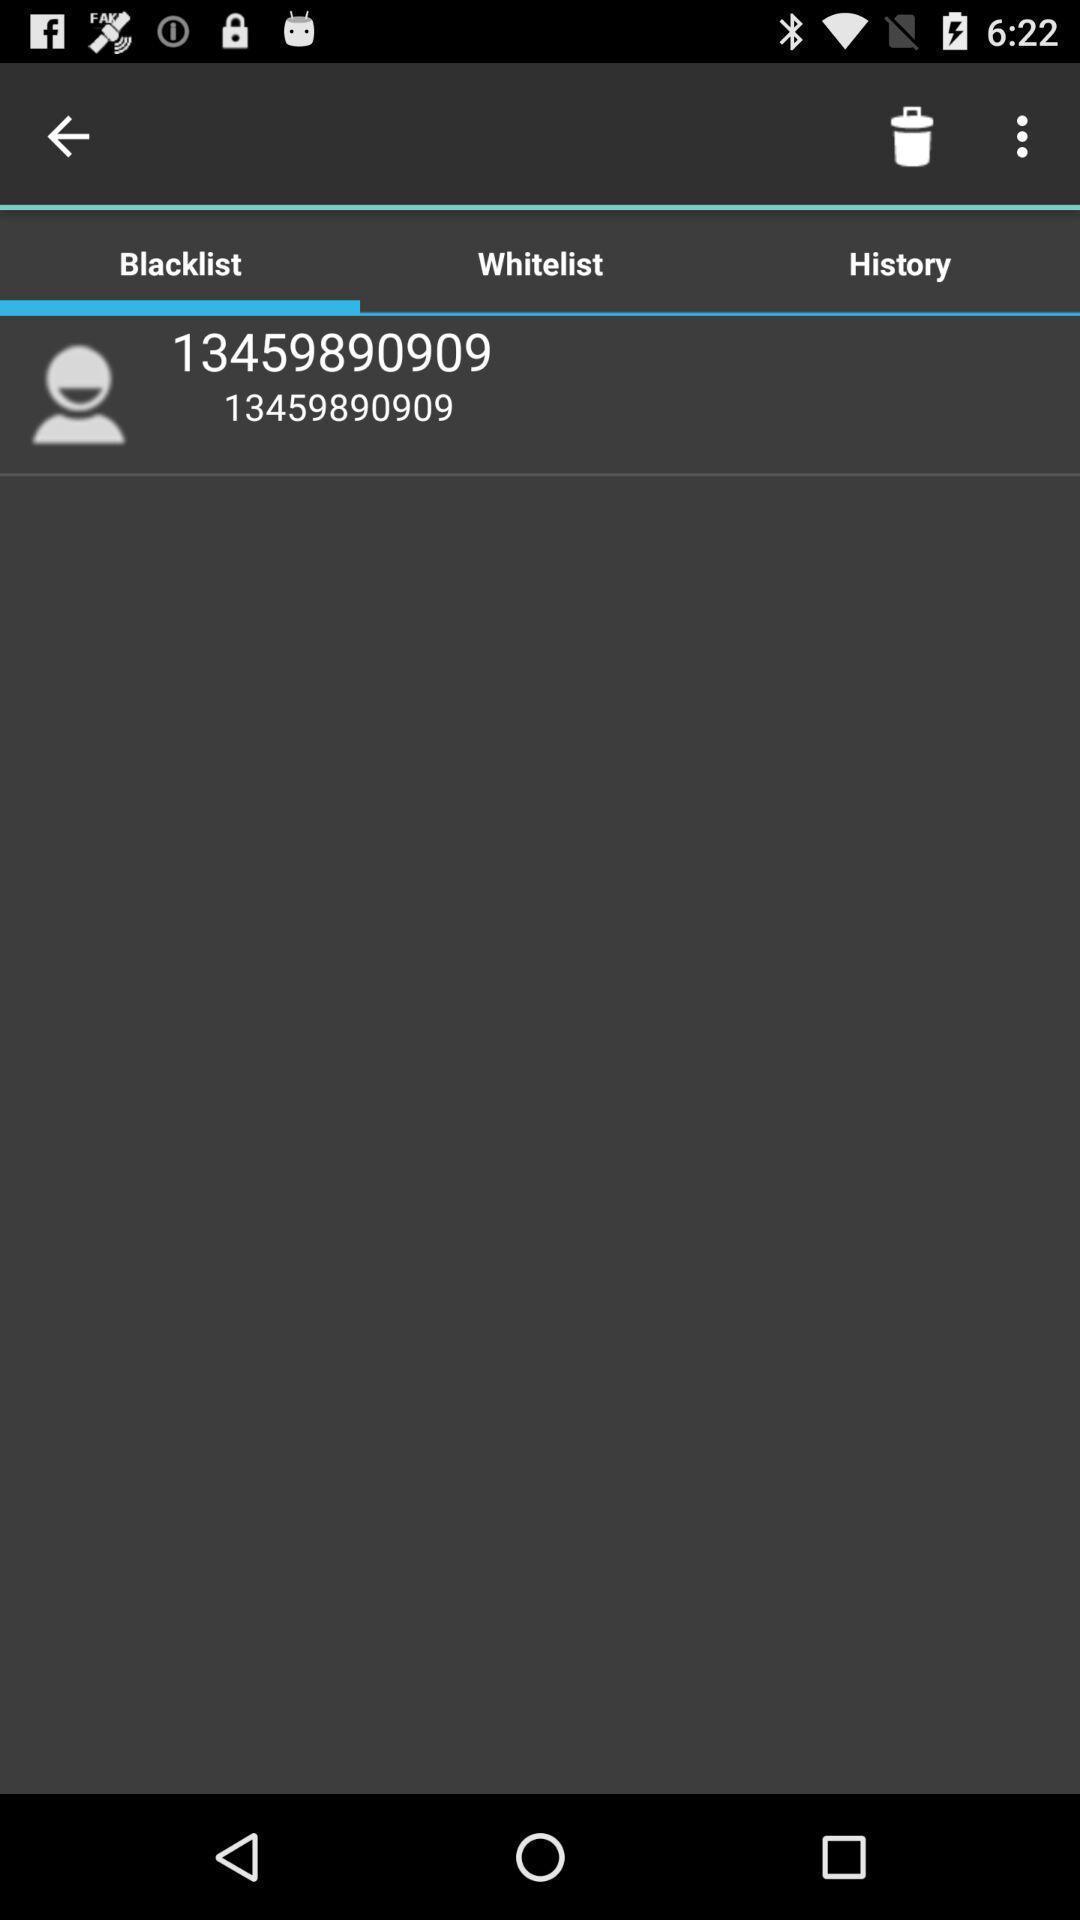Provide a detailed account of this screenshot. Screen displaying a number in blacklist with other options. 